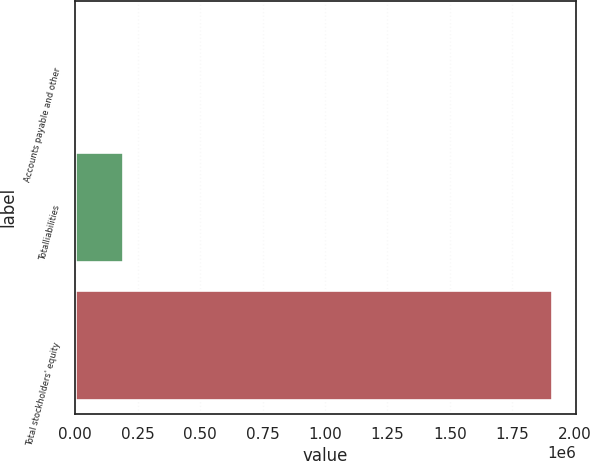Convert chart. <chart><loc_0><loc_0><loc_500><loc_500><bar_chart><fcel>Accounts payable and other<fcel>Totalliabilities<fcel>Total stockholders' equity<nl><fcel>393<fcel>191224<fcel>1.9087e+06<nl></chart> 